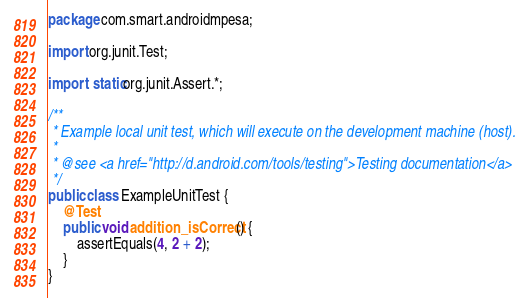Convert code to text. <code><loc_0><loc_0><loc_500><loc_500><_Java_>package com.smart.androidmpesa;

import org.junit.Test;

import static org.junit.Assert.*;

/**
 * Example local unit test, which will execute on the development machine (host).
 *
 * @see <a href="http://d.android.com/tools/testing">Testing documentation</a>
 */
public class ExampleUnitTest {
    @Test
    public void addition_isCorrect() {
        assertEquals(4, 2 + 2);
    }
}</code> 